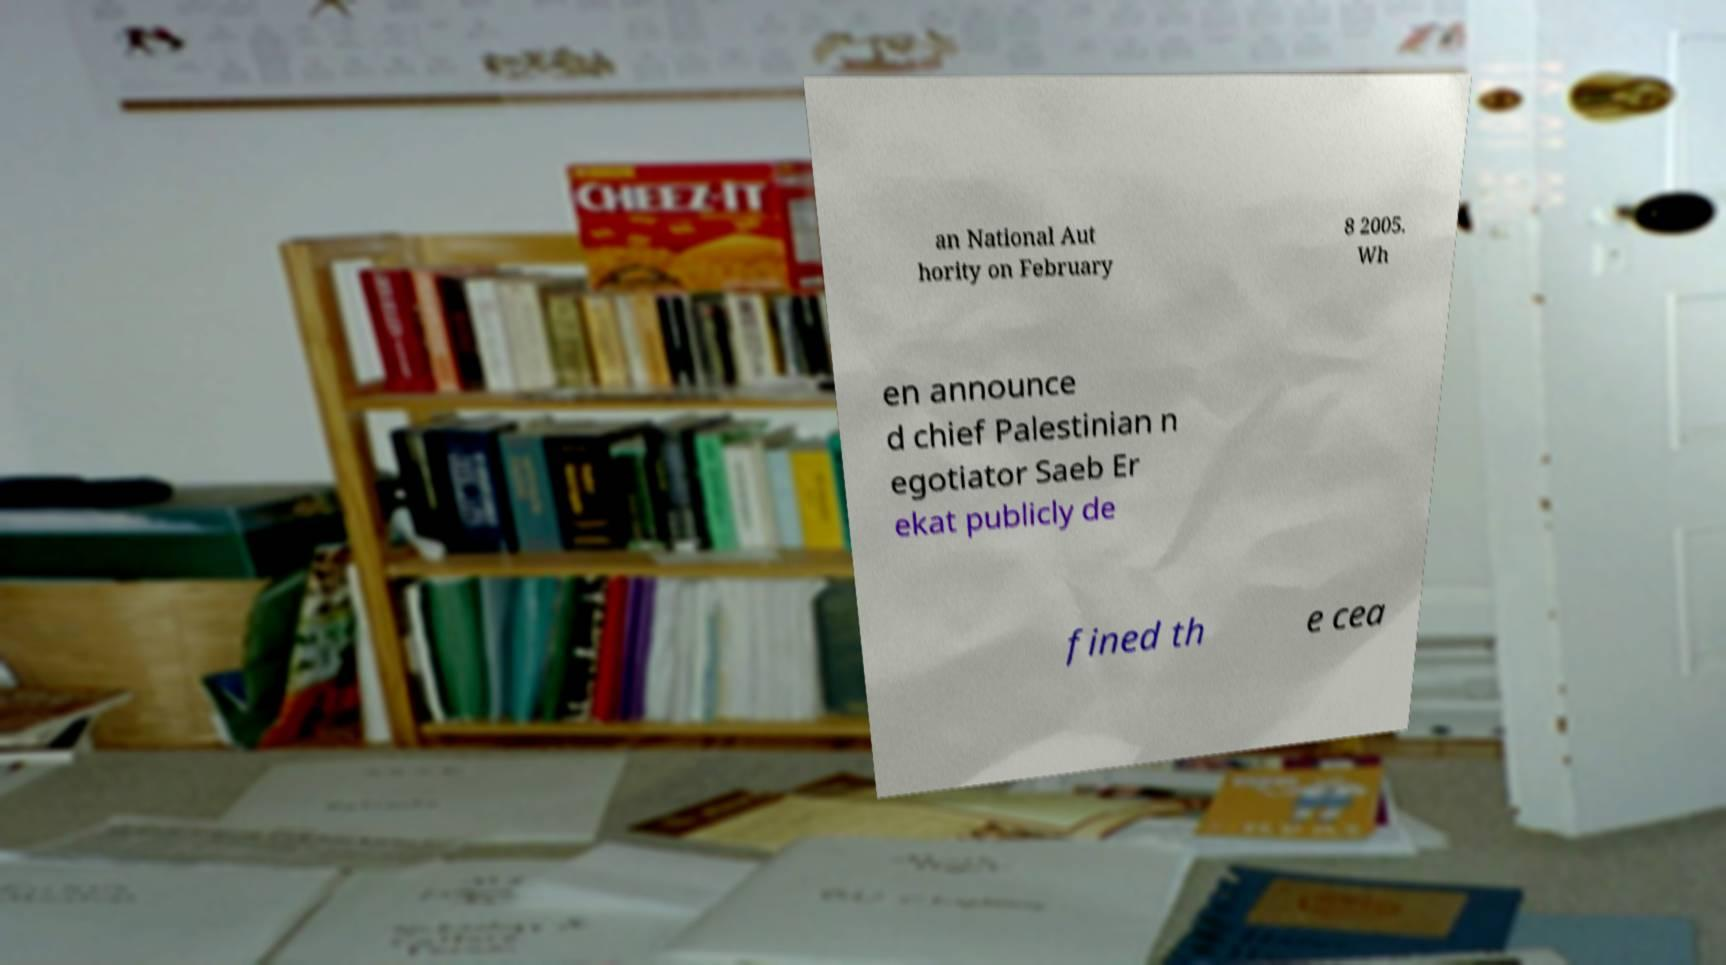I need the written content from this picture converted into text. Can you do that? an National Aut hority on February 8 2005. Wh en announce d chief Palestinian n egotiator Saeb Er ekat publicly de fined th e cea 